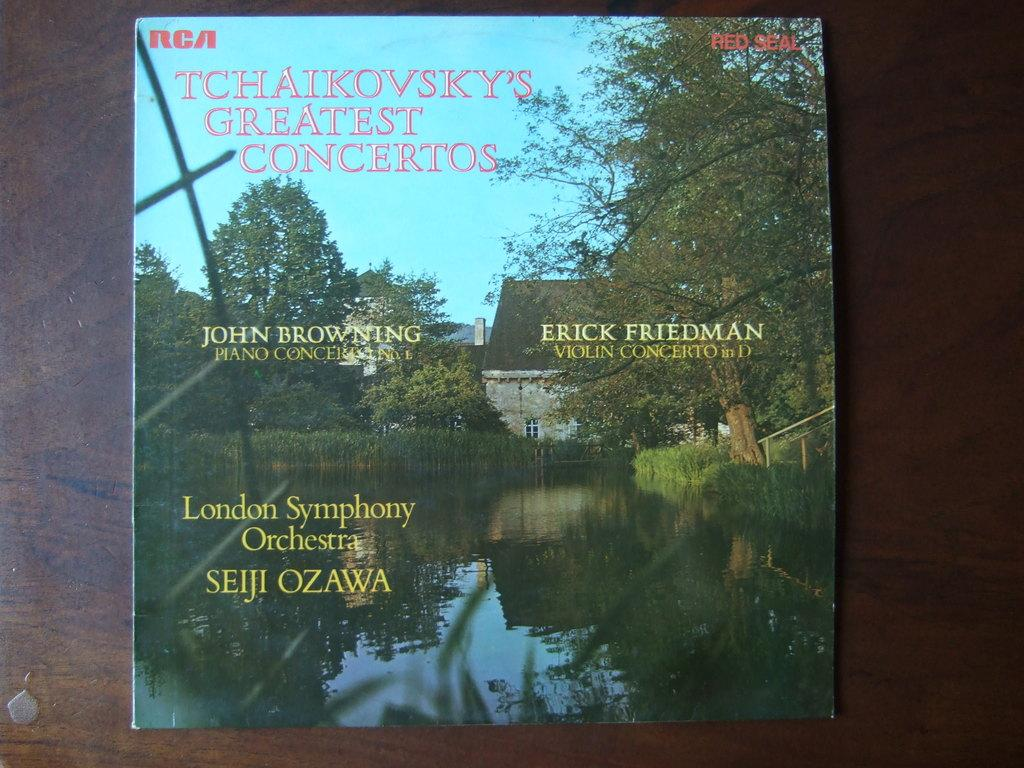<image>
Provide a brief description of the given image. A record album cover contains Tchaikovsky's Greatest Concertos. 